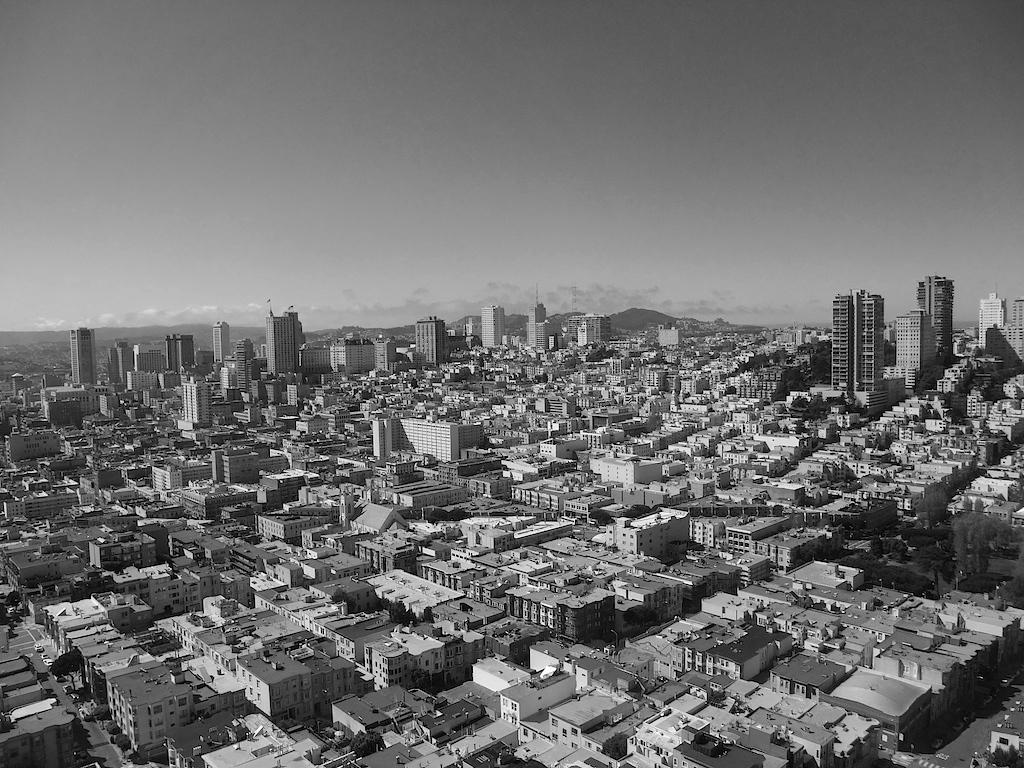Could you give a brief overview of what you see in this image? This is the picture of the view of a place where we have some houses, buildings, roads and some other things around. 